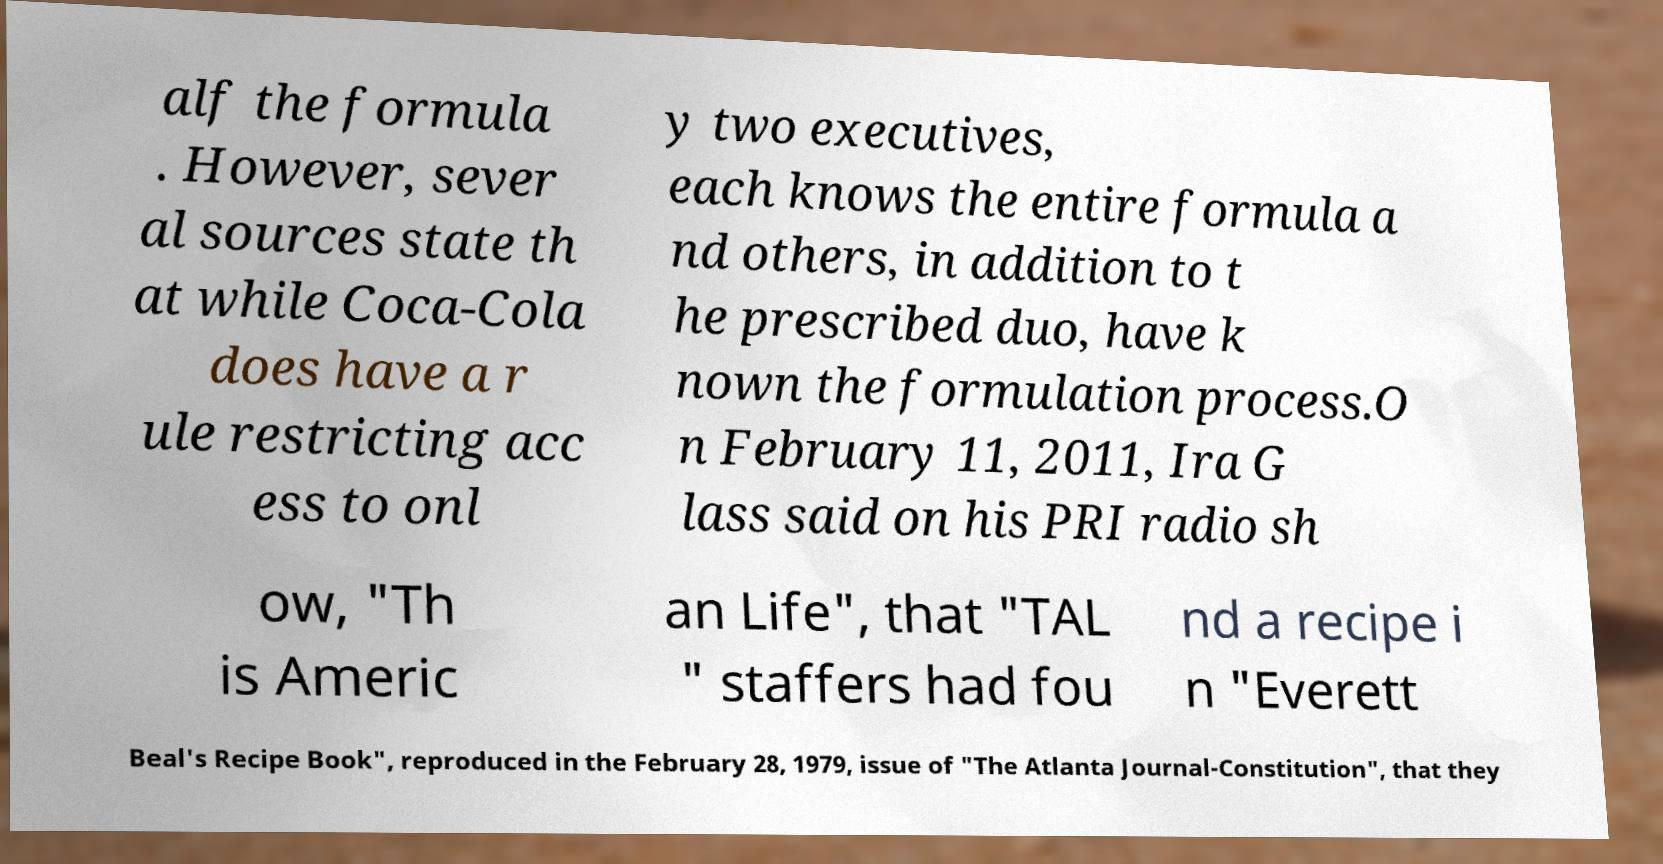Can you accurately transcribe the text from the provided image for me? alf the formula . However, sever al sources state th at while Coca-Cola does have a r ule restricting acc ess to onl y two executives, each knows the entire formula a nd others, in addition to t he prescribed duo, have k nown the formulation process.O n February 11, 2011, Ira G lass said on his PRI radio sh ow, "Th is Americ an Life", that "TAL " staffers had fou nd a recipe i n "Everett Beal's Recipe Book", reproduced in the February 28, 1979, issue of "The Atlanta Journal-Constitution", that they 